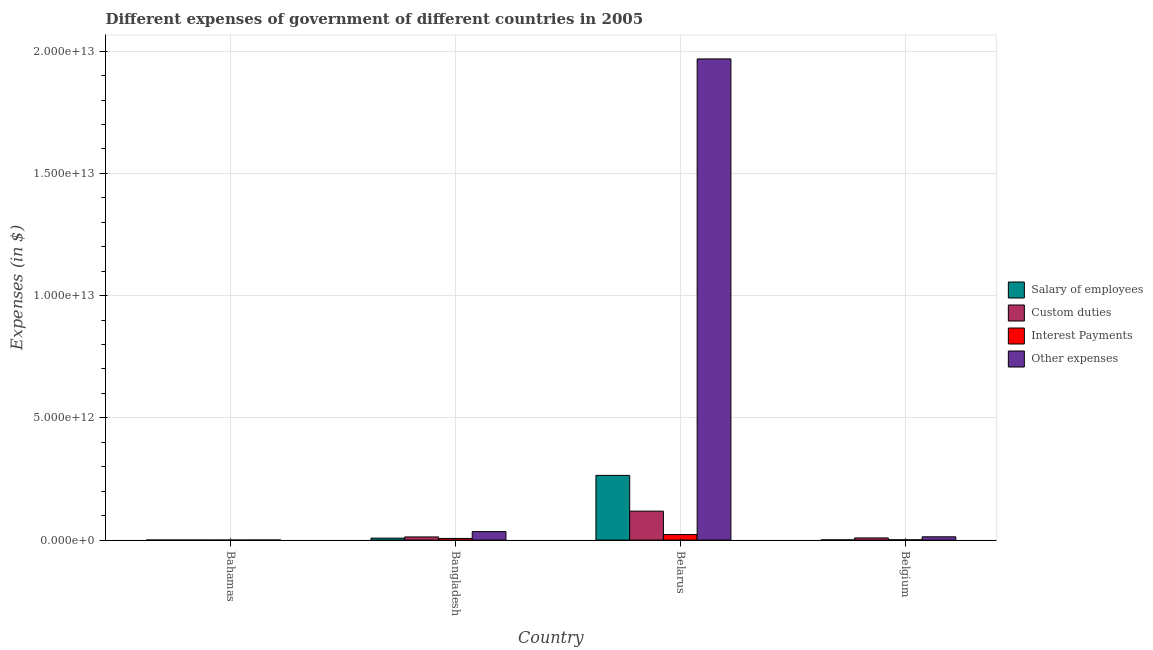Are the number of bars per tick equal to the number of legend labels?
Provide a short and direct response. Yes. Are the number of bars on each tick of the X-axis equal?
Ensure brevity in your answer.  Yes. How many bars are there on the 2nd tick from the right?
Your response must be concise. 4. What is the label of the 1st group of bars from the left?
Make the answer very short. Bahamas. What is the amount spent on salary of employees in Belgium?
Offer a very short reply. 8.74e+09. Across all countries, what is the maximum amount spent on custom duties?
Keep it short and to the point. 1.19e+12. Across all countries, what is the minimum amount spent on other expenses?
Your answer should be very brief. 1.12e+09. In which country was the amount spent on other expenses maximum?
Your response must be concise. Belarus. In which country was the amount spent on custom duties minimum?
Offer a terse response. Bahamas. What is the total amount spent on salary of employees in the graph?
Make the answer very short. 2.74e+12. What is the difference between the amount spent on custom duties in Bahamas and that in Bangladesh?
Ensure brevity in your answer.  -1.29e+11. What is the difference between the amount spent on interest payments in Bahamas and the amount spent on salary of employees in Belgium?
Your answer should be very brief. -8.62e+09. What is the average amount spent on other expenses per country?
Provide a short and direct response. 5.04e+12. What is the difference between the amount spent on custom duties and amount spent on interest payments in Belgium?
Your answer should be very brief. 7.70e+1. In how many countries, is the amount spent on salary of employees greater than 8000000000000 $?
Your answer should be very brief. 0. What is the ratio of the amount spent on interest payments in Bahamas to that in Bangladesh?
Your response must be concise. 0. Is the amount spent on salary of employees in Bangladesh less than that in Belarus?
Keep it short and to the point. Yes. Is the difference between the amount spent on salary of employees in Bahamas and Bangladesh greater than the difference between the amount spent on custom duties in Bahamas and Bangladesh?
Ensure brevity in your answer.  Yes. What is the difference between the highest and the second highest amount spent on other expenses?
Provide a succinct answer. 1.93e+13. What is the difference between the highest and the lowest amount spent on salary of employees?
Offer a very short reply. 2.65e+12. Is it the case that in every country, the sum of the amount spent on other expenses and amount spent on custom duties is greater than the sum of amount spent on salary of employees and amount spent on interest payments?
Offer a very short reply. No. What does the 1st bar from the left in Belgium represents?
Provide a short and direct response. Salary of employees. What does the 3rd bar from the right in Bahamas represents?
Give a very brief answer. Custom duties. Is it the case that in every country, the sum of the amount spent on salary of employees and amount spent on custom duties is greater than the amount spent on interest payments?
Give a very brief answer. Yes. How many bars are there?
Keep it short and to the point. 16. Are all the bars in the graph horizontal?
Make the answer very short. No. How many countries are there in the graph?
Keep it short and to the point. 4. What is the difference between two consecutive major ticks on the Y-axis?
Your answer should be very brief. 5.00e+12. Does the graph contain grids?
Offer a terse response. Yes. How many legend labels are there?
Give a very brief answer. 4. What is the title of the graph?
Your response must be concise. Different expenses of government of different countries in 2005. What is the label or title of the X-axis?
Give a very brief answer. Country. What is the label or title of the Y-axis?
Offer a very short reply. Expenses (in $). What is the Expenses (in $) in Salary of employees in Bahamas?
Your answer should be compact. 4.70e+08. What is the Expenses (in $) of Custom duties in Bahamas?
Your answer should be very brief. 4.64e+08. What is the Expenses (in $) in Interest Payments in Bahamas?
Give a very brief answer. 1.21e+08. What is the Expenses (in $) in Other expenses in Bahamas?
Give a very brief answer. 1.12e+09. What is the Expenses (in $) in Salary of employees in Bangladesh?
Offer a terse response. 8.07e+1. What is the Expenses (in $) in Custom duties in Bangladesh?
Your answer should be compact. 1.30e+11. What is the Expenses (in $) of Interest Payments in Bangladesh?
Offer a terse response. 6.76e+1. What is the Expenses (in $) in Other expenses in Bangladesh?
Offer a terse response. 3.48e+11. What is the Expenses (in $) in Salary of employees in Belarus?
Your response must be concise. 2.65e+12. What is the Expenses (in $) in Custom duties in Belarus?
Offer a terse response. 1.19e+12. What is the Expenses (in $) of Interest Payments in Belarus?
Keep it short and to the point. 2.26e+11. What is the Expenses (in $) in Other expenses in Belarus?
Keep it short and to the point. 1.97e+13. What is the Expenses (in $) in Salary of employees in Belgium?
Make the answer very short. 8.74e+09. What is the Expenses (in $) in Custom duties in Belgium?
Make the answer very short. 8.91e+1. What is the Expenses (in $) in Interest Payments in Belgium?
Provide a succinct answer. 1.22e+1. What is the Expenses (in $) of Other expenses in Belgium?
Provide a succinct answer. 1.35e+11. Across all countries, what is the maximum Expenses (in $) in Salary of employees?
Keep it short and to the point. 2.65e+12. Across all countries, what is the maximum Expenses (in $) of Custom duties?
Ensure brevity in your answer.  1.19e+12. Across all countries, what is the maximum Expenses (in $) in Interest Payments?
Your response must be concise. 2.26e+11. Across all countries, what is the maximum Expenses (in $) of Other expenses?
Keep it short and to the point. 1.97e+13. Across all countries, what is the minimum Expenses (in $) in Salary of employees?
Your answer should be very brief. 4.70e+08. Across all countries, what is the minimum Expenses (in $) in Custom duties?
Offer a terse response. 4.64e+08. Across all countries, what is the minimum Expenses (in $) of Interest Payments?
Ensure brevity in your answer.  1.21e+08. Across all countries, what is the minimum Expenses (in $) of Other expenses?
Offer a very short reply. 1.12e+09. What is the total Expenses (in $) in Salary of employees in the graph?
Offer a terse response. 2.74e+12. What is the total Expenses (in $) of Custom duties in the graph?
Your answer should be compact. 1.40e+12. What is the total Expenses (in $) of Interest Payments in the graph?
Provide a short and direct response. 3.06e+11. What is the total Expenses (in $) in Other expenses in the graph?
Your answer should be compact. 2.02e+13. What is the difference between the Expenses (in $) in Salary of employees in Bahamas and that in Bangladesh?
Provide a short and direct response. -8.03e+1. What is the difference between the Expenses (in $) in Custom duties in Bahamas and that in Bangladesh?
Offer a terse response. -1.29e+11. What is the difference between the Expenses (in $) in Interest Payments in Bahamas and that in Bangladesh?
Your answer should be compact. -6.75e+1. What is the difference between the Expenses (in $) of Other expenses in Bahamas and that in Bangladesh?
Make the answer very short. -3.47e+11. What is the difference between the Expenses (in $) in Salary of employees in Bahamas and that in Belarus?
Ensure brevity in your answer.  -2.65e+12. What is the difference between the Expenses (in $) in Custom duties in Bahamas and that in Belarus?
Offer a very short reply. -1.18e+12. What is the difference between the Expenses (in $) of Interest Payments in Bahamas and that in Belarus?
Keep it short and to the point. -2.26e+11. What is the difference between the Expenses (in $) of Other expenses in Bahamas and that in Belarus?
Your answer should be compact. -1.97e+13. What is the difference between the Expenses (in $) in Salary of employees in Bahamas and that in Belgium?
Your answer should be very brief. -8.27e+09. What is the difference between the Expenses (in $) of Custom duties in Bahamas and that in Belgium?
Offer a terse response. -8.87e+1. What is the difference between the Expenses (in $) in Interest Payments in Bahamas and that in Belgium?
Offer a very short reply. -1.21e+1. What is the difference between the Expenses (in $) in Other expenses in Bahamas and that in Belgium?
Provide a succinct answer. -1.34e+11. What is the difference between the Expenses (in $) of Salary of employees in Bangladesh and that in Belarus?
Provide a short and direct response. -2.57e+12. What is the difference between the Expenses (in $) of Custom duties in Bangladesh and that in Belarus?
Provide a succinct answer. -1.06e+12. What is the difference between the Expenses (in $) in Interest Payments in Bangladesh and that in Belarus?
Ensure brevity in your answer.  -1.58e+11. What is the difference between the Expenses (in $) in Other expenses in Bangladesh and that in Belarus?
Provide a succinct answer. -1.93e+13. What is the difference between the Expenses (in $) in Salary of employees in Bangladesh and that in Belgium?
Give a very brief answer. 7.20e+1. What is the difference between the Expenses (in $) of Custom duties in Bangladesh and that in Belgium?
Provide a succinct answer. 4.04e+1. What is the difference between the Expenses (in $) of Interest Payments in Bangladesh and that in Belgium?
Offer a terse response. 5.54e+1. What is the difference between the Expenses (in $) of Other expenses in Bangladesh and that in Belgium?
Provide a succinct answer. 2.13e+11. What is the difference between the Expenses (in $) in Salary of employees in Belarus and that in Belgium?
Make the answer very short. 2.64e+12. What is the difference between the Expenses (in $) of Custom duties in Belarus and that in Belgium?
Offer a very short reply. 1.10e+12. What is the difference between the Expenses (in $) of Interest Payments in Belarus and that in Belgium?
Your answer should be very brief. 2.14e+11. What is the difference between the Expenses (in $) in Other expenses in Belarus and that in Belgium?
Your answer should be very brief. 1.95e+13. What is the difference between the Expenses (in $) in Salary of employees in Bahamas and the Expenses (in $) in Custom duties in Bangladesh?
Your answer should be very brief. -1.29e+11. What is the difference between the Expenses (in $) in Salary of employees in Bahamas and the Expenses (in $) in Interest Payments in Bangladesh?
Offer a very short reply. -6.71e+1. What is the difference between the Expenses (in $) of Salary of employees in Bahamas and the Expenses (in $) of Other expenses in Bangladesh?
Offer a terse response. -3.47e+11. What is the difference between the Expenses (in $) of Custom duties in Bahamas and the Expenses (in $) of Interest Payments in Bangladesh?
Keep it short and to the point. -6.71e+1. What is the difference between the Expenses (in $) in Custom duties in Bahamas and the Expenses (in $) in Other expenses in Bangladesh?
Give a very brief answer. -3.47e+11. What is the difference between the Expenses (in $) in Interest Payments in Bahamas and the Expenses (in $) in Other expenses in Bangladesh?
Your answer should be very brief. -3.48e+11. What is the difference between the Expenses (in $) of Salary of employees in Bahamas and the Expenses (in $) of Custom duties in Belarus?
Your response must be concise. -1.18e+12. What is the difference between the Expenses (in $) of Salary of employees in Bahamas and the Expenses (in $) of Interest Payments in Belarus?
Make the answer very short. -2.26e+11. What is the difference between the Expenses (in $) of Salary of employees in Bahamas and the Expenses (in $) of Other expenses in Belarus?
Ensure brevity in your answer.  -1.97e+13. What is the difference between the Expenses (in $) in Custom duties in Bahamas and the Expenses (in $) in Interest Payments in Belarus?
Ensure brevity in your answer.  -2.26e+11. What is the difference between the Expenses (in $) in Custom duties in Bahamas and the Expenses (in $) in Other expenses in Belarus?
Your answer should be very brief. -1.97e+13. What is the difference between the Expenses (in $) of Interest Payments in Bahamas and the Expenses (in $) of Other expenses in Belarus?
Your response must be concise. -1.97e+13. What is the difference between the Expenses (in $) in Salary of employees in Bahamas and the Expenses (in $) in Custom duties in Belgium?
Your answer should be very brief. -8.87e+1. What is the difference between the Expenses (in $) in Salary of employees in Bahamas and the Expenses (in $) in Interest Payments in Belgium?
Offer a very short reply. -1.17e+1. What is the difference between the Expenses (in $) in Salary of employees in Bahamas and the Expenses (in $) in Other expenses in Belgium?
Your response must be concise. -1.34e+11. What is the difference between the Expenses (in $) in Custom duties in Bahamas and the Expenses (in $) in Interest Payments in Belgium?
Make the answer very short. -1.17e+1. What is the difference between the Expenses (in $) in Custom duties in Bahamas and the Expenses (in $) in Other expenses in Belgium?
Your response must be concise. -1.34e+11. What is the difference between the Expenses (in $) in Interest Payments in Bahamas and the Expenses (in $) in Other expenses in Belgium?
Ensure brevity in your answer.  -1.35e+11. What is the difference between the Expenses (in $) of Salary of employees in Bangladesh and the Expenses (in $) of Custom duties in Belarus?
Provide a succinct answer. -1.10e+12. What is the difference between the Expenses (in $) of Salary of employees in Bangladesh and the Expenses (in $) of Interest Payments in Belarus?
Keep it short and to the point. -1.45e+11. What is the difference between the Expenses (in $) in Salary of employees in Bangladesh and the Expenses (in $) in Other expenses in Belarus?
Provide a short and direct response. -1.96e+13. What is the difference between the Expenses (in $) of Custom duties in Bangladesh and the Expenses (in $) of Interest Payments in Belarus?
Your response must be concise. -9.64e+1. What is the difference between the Expenses (in $) of Custom duties in Bangladesh and the Expenses (in $) of Other expenses in Belarus?
Your response must be concise. -1.96e+13. What is the difference between the Expenses (in $) in Interest Payments in Bangladesh and the Expenses (in $) in Other expenses in Belarus?
Provide a succinct answer. -1.96e+13. What is the difference between the Expenses (in $) in Salary of employees in Bangladesh and the Expenses (in $) in Custom duties in Belgium?
Your answer should be compact. -8.42e+09. What is the difference between the Expenses (in $) of Salary of employees in Bangladesh and the Expenses (in $) of Interest Payments in Belgium?
Your response must be concise. 6.86e+1. What is the difference between the Expenses (in $) in Salary of employees in Bangladesh and the Expenses (in $) in Other expenses in Belgium?
Ensure brevity in your answer.  -5.40e+1. What is the difference between the Expenses (in $) in Custom duties in Bangladesh and the Expenses (in $) in Interest Payments in Belgium?
Provide a succinct answer. 1.17e+11. What is the difference between the Expenses (in $) in Custom duties in Bangladesh and the Expenses (in $) in Other expenses in Belgium?
Make the answer very short. -5.14e+09. What is the difference between the Expenses (in $) of Interest Payments in Bangladesh and the Expenses (in $) of Other expenses in Belgium?
Provide a short and direct response. -6.71e+1. What is the difference between the Expenses (in $) in Salary of employees in Belarus and the Expenses (in $) in Custom duties in Belgium?
Provide a succinct answer. 2.56e+12. What is the difference between the Expenses (in $) in Salary of employees in Belarus and the Expenses (in $) in Interest Payments in Belgium?
Ensure brevity in your answer.  2.64e+12. What is the difference between the Expenses (in $) in Salary of employees in Belarus and the Expenses (in $) in Other expenses in Belgium?
Keep it short and to the point. 2.51e+12. What is the difference between the Expenses (in $) of Custom duties in Belarus and the Expenses (in $) of Interest Payments in Belgium?
Your answer should be very brief. 1.17e+12. What is the difference between the Expenses (in $) in Custom duties in Belarus and the Expenses (in $) in Other expenses in Belgium?
Give a very brief answer. 1.05e+12. What is the difference between the Expenses (in $) in Interest Payments in Belarus and the Expenses (in $) in Other expenses in Belgium?
Give a very brief answer. 9.13e+1. What is the average Expenses (in $) of Salary of employees per country?
Offer a terse response. 6.84e+11. What is the average Expenses (in $) in Custom duties per country?
Provide a short and direct response. 3.51e+11. What is the average Expenses (in $) of Interest Payments per country?
Give a very brief answer. 7.65e+1. What is the average Expenses (in $) in Other expenses per country?
Give a very brief answer. 5.04e+12. What is the difference between the Expenses (in $) of Salary of employees and Expenses (in $) of Custom duties in Bahamas?
Ensure brevity in your answer.  5.78e+06. What is the difference between the Expenses (in $) in Salary of employees and Expenses (in $) in Interest Payments in Bahamas?
Offer a very short reply. 3.49e+08. What is the difference between the Expenses (in $) of Salary of employees and Expenses (in $) of Other expenses in Bahamas?
Make the answer very short. -6.47e+08. What is the difference between the Expenses (in $) in Custom duties and Expenses (in $) in Interest Payments in Bahamas?
Your response must be concise. 3.43e+08. What is the difference between the Expenses (in $) of Custom duties and Expenses (in $) of Other expenses in Bahamas?
Provide a short and direct response. -6.53e+08. What is the difference between the Expenses (in $) in Interest Payments and Expenses (in $) in Other expenses in Bahamas?
Keep it short and to the point. -9.96e+08. What is the difference between the Expenses (in $) of Salary of employees and Expenses (in $) of Custom duties in Bangladesh?
Ensure brevity in your answer.  -4.88e+1. What is the difference between the Expenses (in $) in Salary of employees and Expenses (in $) in Interest Payments in Bangladesh?
Give a very brief answer. 1.32e+1. What is the difference between the Expenses (in $) of Salary of employees and Expenses (in $) of Other expenses in Bangladesh?
Offer a very short reply. -2.67e+11. What is the difference between the Expenses (in $) in Custom duties and Expenses (in $) in Interest Payments in Bangladesh?
Give a very brief answer. 6.20e+1. What is the difference between the Expenses (in $) of Custom duties and Expenses (in $) of Other expenses in Bangladesh?
Give a very brief answer. -2.18e+11. What is the difference between the Expenses (in $) in Interest Payments and Expenses (in $) in Other expenses in Bangladesh?
Give a very brief answer. -2.80e+11. What is the difference between the Expenses (in $) in Salary of employees and Expenses (in $) in Custom duties in Belarus?
Ensure brevity in your answer.  1.46e+12. What is the difference between the Expenses (in $) of Salary of employees and Expenses (in $) of Interest Payments in Belarus?
Offer a very short reply. 2.42e+12. What is the difference between the Expenses (in $) of Salary of employees and Expenses (in $) of Other expenses in Belarus?
Give a very brief answer. -1.70e+13. What is the difference between the Expenses (in $) of Custom duties and Expenses (in $) of Interest Payments in Belarus?
Your answer should be compact. 9.59e+11. What is the difference between the Expenses (in $) in Custom duties and Expenses (in $) in Other expenses in Belarus?
Make the answer very short. -1.85e+13. What is the difference between the Expenses (in $) in Interest Payments and Expenses (in $) in Other expenses in Belarus?
Provide a succinct answer. -1.95e+13. What is the difference between the Expenses (in $) of Salary of employees and Expenses (in $) of Custom duties in Belgium?
Ensure brevity in your answer.  -8.04e+1. What is the difference between the Expenses (in $) of Salary of employees and Expenses (in $) of Interest Payments in Belgium?
Provide a succinct answer. -3.44e+09. What is the difference between the Expenses (in $) in Salary of employees and Expenses (in $) in Other expenses in Belgium?
Your response must be concise. -1.26e+11. What is the difference between the Expenses (in $) in Custom duties and Expenses (in $) in Interest Payments in Belgium?
Keep it short and to the point. 7.70e+1. What is the difference between the Expenses (in $) in Custom duties and Expenses (in $) in Other expenses in Belgium?
Offer a very short reply. -4.55e+1. What is the difference between the Expenses (in $) of Interest Payments and Expenses (in $) of Other expenses in Belgium?
Offer a very short reply. -1.23e+11. What is the ratio of the Expenses (in $) in Salary of employees in Bahamas to that in Bangladesh?
Make the answer very short. 0.01. What is the ratio of the Expenses (in $) in Custom duties in Bahamas to that in Bangladesh?
Offer a very short reply. 0. What is the ratio of the Expenses (in $) of Interest Payments in Bahamas to that in Bangladesh?
Your response must be concise. 0. What is the ratio of the Expenses (in $) of Other expenses in Bahamas to that in Bangladesh?
Offer a terse response. 0. What is the ratio of the Expenses (in $) of Salary of employees in Bahamas to that in Belarus?
Your response must be concise. 0. What is the ratio of the Expenses (in $) in Custom duties in Bahamas to that in Belarus?
Keep it short and to the point. 0. What is the ratio of the Expenses (in $) in Interest Payments in Bahamas to that in Belarus?
Provide a succinct answer. 0. What is the ratio of the Expenses (in $) of Other expenses in Bahamas to that in Belarus?
Make the answer very short. 0. What is the ratio of the Expenses (in $) in Salary of employees in Bahamas to that in Belgium?
Your response must be concise. 0.05. What is the ratio of the Expenses (in $) of Custom duties in Bahamas to that in Belgium?
Your answer should be very brief. 0.01. What is the ratio of the Expenses (in $) of Interest Payments in Bahamas to that in Belgium?
Your answer should be very brief. 0.01. What is the ratio of the Expenses (in $) of Other expenses in Bahamas to that in Belgium?
Your answer should be very brief. 0.01. What is the ratio of the Expenses (in $) of Salary of employees in Bangladesh to that in Belarus?
Provide a succinct answer. 0.03. What is the ratio of the Expenses (in $) of Custom duties in Bangladesh to that in Belarus?
Offer a very short reply. 0.11. What is the ratio of the Expenses (in $) of Interest Payments in Bangladesh to that in Belarus?
Give a very brief answer. 0.3. What is the ratio of the Expenses (in $) in Other expenses in Bangladesh to that in Belarus?
Your answer should be very brief. 0.02. What is the ratio of the Expenses (in $) of Salary of employees in Bangladesh to that in Belgium?
Provide a succinct answer. 9.24. What is the ratio of the Expenses (in $) in Custom duties in Bangladesh to that in Belgium?
Ensure brevity in your answer.  1.45. What is the ratio of the Expenses (in $) in Interest Payments in Bangladesh to that in Belgium?
Provide a short and direct response. 5.55. What is the ratio of the Expenses (in $) in Other expenses in Bangladesh to that in Belgium?
Your response must be concise. 2.58. What is the ratio of the Expenses (in $) in Salary of employees in Belarus to that in Belgium?
Offer a terse response. 302.98. What is the ratio of the Expenses (in $) in Custom duties in Belarus to that in Belgium?
Provide a succinct answer. 13.29. What is the ratio of the Expenses (in $) of Interest Payments in Belarus to that in Belgium?
Provide a short and direct response. 18.56. What is the ratio of the Expenses (in $) in Other expenses in Belarus to that in Belgium?
Make the answer very short. 146.14. What is the difference between the highest and the second highest Expenses (in $) of Salary of employees?
Make the answer very short. 2.57e+12. What is the difference between the highest and the second highest Expenses (in $) of Custom duties?
Make the answer very short. 1.06e+12. What is the difference between the highest and the second highest Expenses (in $) of Interest Payments?
Your answer should be compact. 1.58e+11. What is the difference between the highest and the second highest Expenses (in $) in Other expenses?
Provide a short and direct response. 1.93e+13. What is the difference between the highest and the lowest Expenses (in $) of Salary of employees?
Ensure brevity in your answer.  2.65e+12. What is the difference between the highest and the lowest Expenses (in $) of Custom duties?
Provide a succinct answer. 1.18e+12. What is the difference between the highest and the lowest Expenses (in $) of Interest Payments?
Offer a terse response. 2.26e+11. What is the difference between the highest and the lowest Expenses (in $) in Other expenses?
Your answer should be very brief. 1.97e+13. 